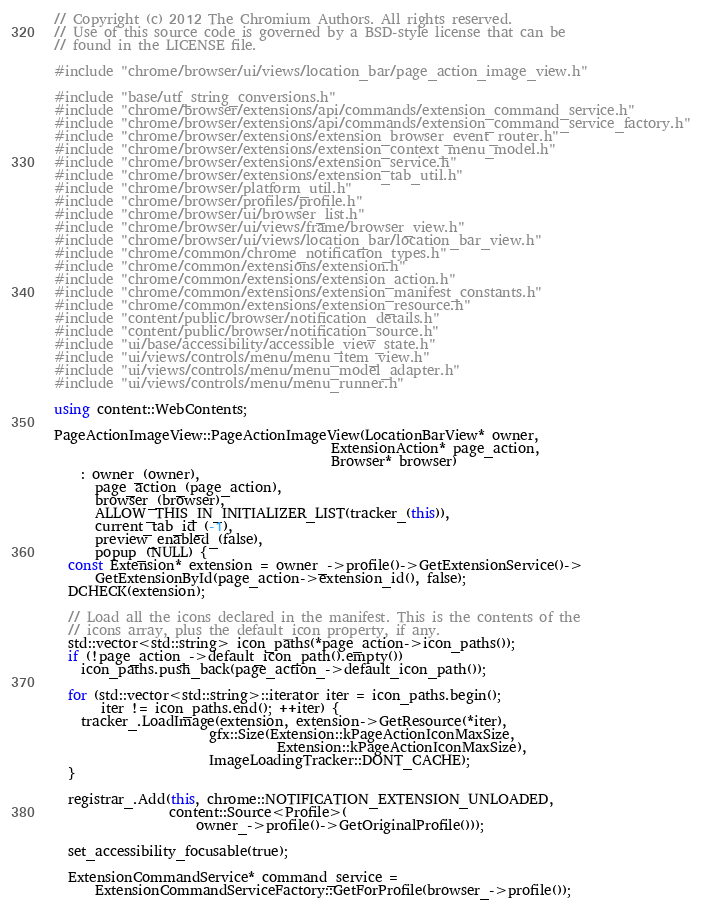<code> <loc_0><loc_0><loc_500><loc_500><_C++_>// Copyright (c) 2012 The Chromium Authors. All rights reserved.
// Use of this source code is governed by a BSD-style license that can be
// found in the LICENSE file.

#include "chrome/browser/ui/views/location_bar/page_action_image_view.h"

#include "base/utf_string_conversions.h"
#include "chrome/browser/extensions/api/commands/extension_command_service.h"
#include "chrome/browser/extensions/api/commands/extension_command_service_factory.h"
#include "chrome/browser/extensions/extension_browser_event_router.h"
#include "chrome/browser/extensions/extension_context_menu_model.h"
#include "chrome/browser/extensions/extension_service.h"
#include "chrome/browser/extensions/extension_tab_util.h"
#include "chrome/browser/platform_util.h"
#include "chrome/browser/profiles/profile.h"
#include "chrome/browser/ui/browser_list.h"
#include "chrome/browser/ui/views/frame/browser_view.h"
#include "chrome/browser/ui/views/location_bar/location_bar_view.h"
#include "chrome/common/chrome_notification_types.h"
#include "chrome/common/extensions/extension.h"
#include "chrome/common/extensions/extension_action.h"
#include "chrome/common/extensions/extension_manifest_constants.h"
#include "chrome/common/extensions/extension_resource.h"
#include "content/public/browser/notification_details.h"
#include "content/public/browser/notification_source.h"
#include "ui/base/accessibility/accessible_view_state.h"
#include "ui/views/controls/menu/menu_item_view.h"
#include "ui/views/controls/menu/menu_model_adapter.h"
#include "ui/views/controls/menu/menu_runner.h"

using content::WebContents;

PageActionImageView::PageActionImageView(LocationBarView* owner,
                                         ExtensionAction* page_action,
                                         Browser* browser)
    : owner_(owner),
      page_action_(page_action),
      browser_(browser),
      ALLOW_THIS_IN_INITIALIZER_LIST(tracker_(this)),
      current_tab_id_(-1),
      preview_enabled_(false),
      popup_(NULL) {
  const Extension* extension = owner_->profile()->GetExtensionService()->
      GetExtensionById(page_action->extension_id(), false);
  DCHECK(extension);

  // Load all the icons declared in the manifest. This is the contents of the
  // icons array, plus the default_icon property, if any.
  std::vector<std::string> icon_paths(*page_action->icon_paths());
  if (!page_action_->default_icon_path().empty())
    icon_paths.push_back(page_action_->default_icon_path());

  for (std::vector<std::string>::iterator iter = icon_paths.begin();
       iter != icon_paths.end(); ++iter) {
    tracker_.LoadImage(extension, extension->GetResource(*iter),
                       gfx::Size(Extension::kPageActionIconMaxSize,
                                 Extension::kPageActionIconMaxSize),
                       ImageLoadingTracker::DONT_CACHE);
  }

  registrar_.Add(this, chrome::NOTIFICATION_EXTENSION_UNLOADED,
                 content::Source<Profile>(
                     owner_->profile()->GetOriginalProfile()));

  set_accessibility_focusable(true);

  ExtensionCommandService* command_service =
      ExtensionCommandServiceFactory::GetForProfile(browser_->profile());</code> 